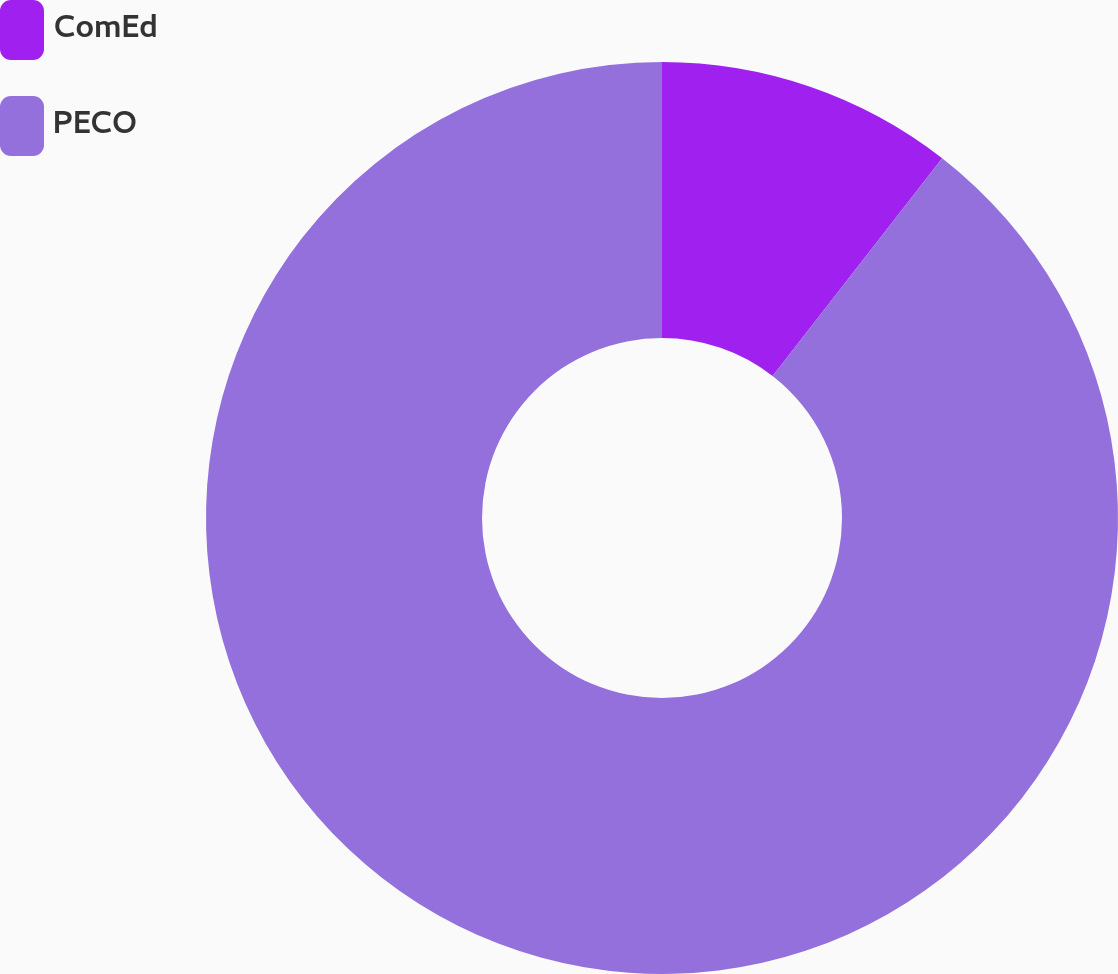<chart> <loc_0><loc_0><loc_500><loc_500><pie_chart><fcel>ComEd<fcel>PECO<nl><fcel>10.53%<fcel>89.47%<nl></chart> 